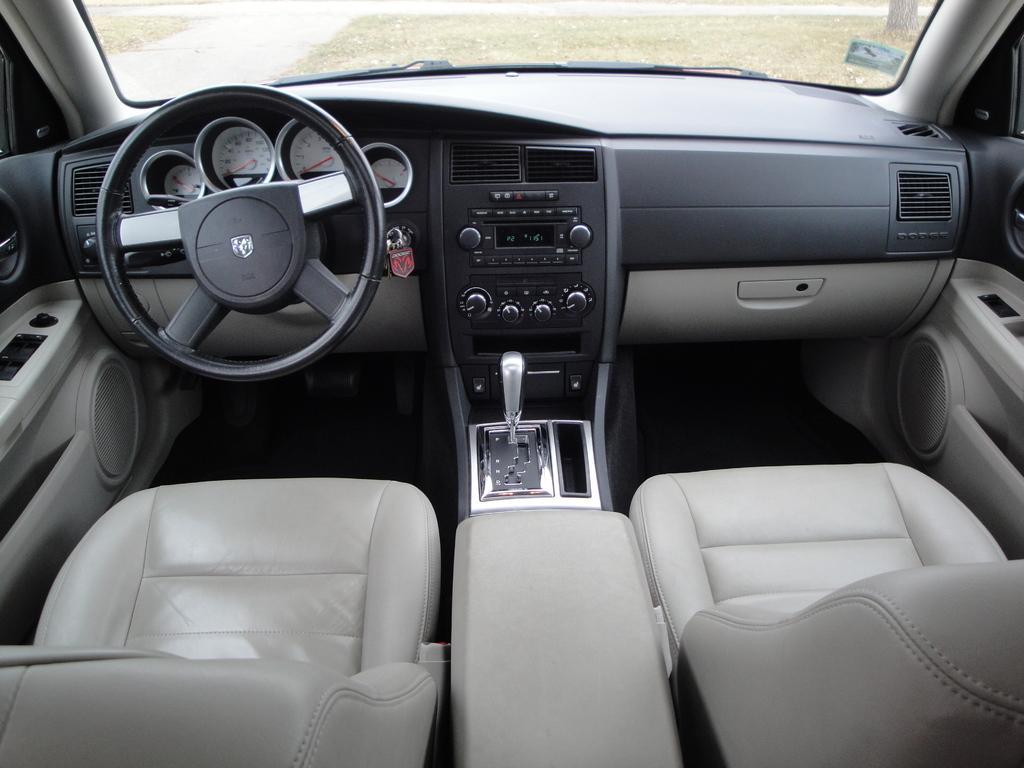Please provide a concise description of this image. This is the picture of a vehicle in which there is a steering, gear, readings, buttons, seats and some other things. 